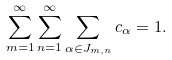Convert formula to latex. <formula><loc_0><loc_0><loc_500><loc_500>\sum _ { m = 1 } ^ { \infty } \sum _ { n = 1 } ^ { \infty } \sum _ { \alpha \in J _ { m , n } } c _ { \alpha } = 1 .</formula> 